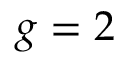Convert formula to latex. <formula><loc_0><loc_0><loc_500><loc_500>g = 2</formula> 